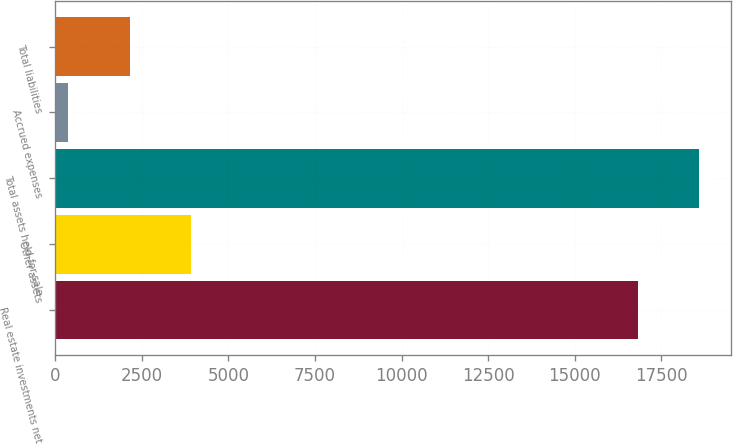<chart> <loc_0><loc_0><loc_500><loc_500><bar_chart><fcel>Real estate investments net<fcel>Other assets<fcel>Total assets held-for-sale<fcel>Accrued expenses<fcel>Total liabilities<nl><fcel>16813<fcel>3929.4<fcel>18588.2<fcel>379<fcel>2154.2<nl></chart> 